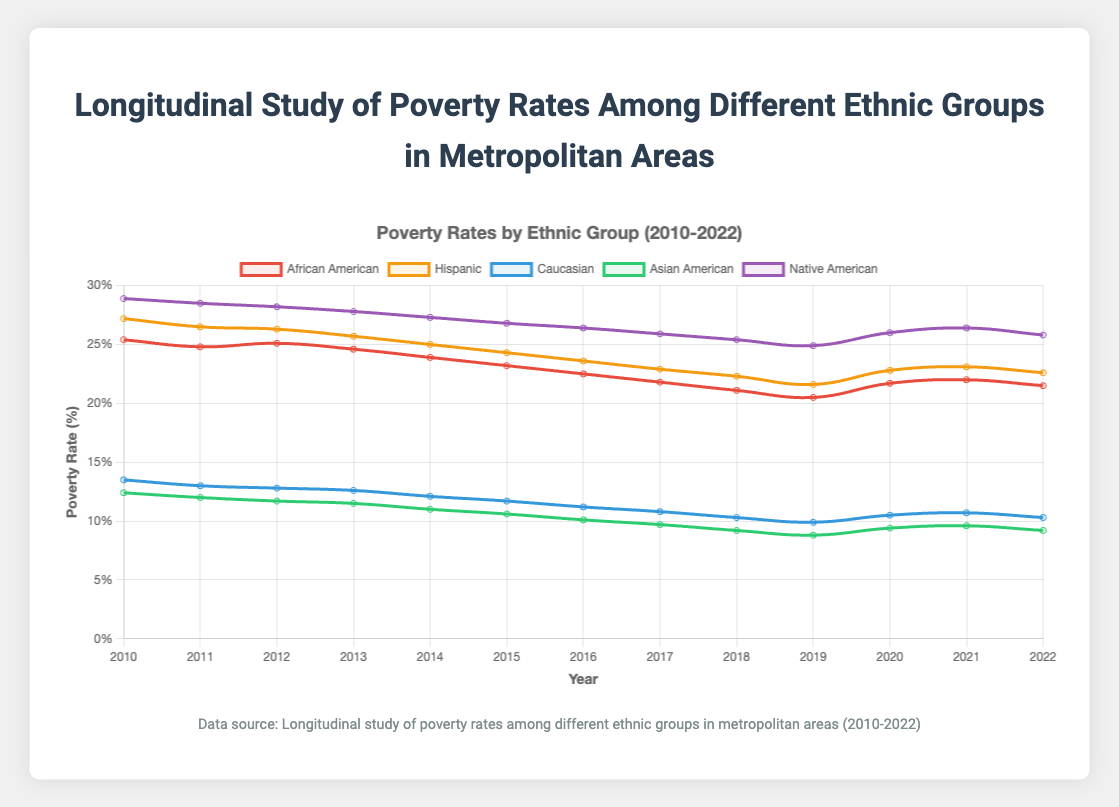What are the highest and lowest poverty rates for the Hispanic group between 2010 and 2022? The highest poverty rate for Hispanics is in 2010 at 27.2%, and the lowest is in 2019 at 21.6%
Answer: Highest: 27.2%, Lowest: 21.6% Which ethnic group had the lowest poverty rate in 2012? By examining the values for 2012, Caucasians had the lowest poverty rate at 12.8%
Answer: Caucasian Between 2010 and 2013, did the Native American poverty rate increase or decrease overall? In 2010, the rate is 28.9%, and by 2013 it is 27.8%. Since 27.8% is less than 28.9%, the overall trend is a decrease
Answer: Decrease Which group had the largest rise in poverty rate from 2019 to 2020? Between 2019 and 2020, the change for African Americans is +1.2, for Hispanics is +1.2, for Caucasians is +0.6, for Asian Americans is +0.6, and for Native Americans is +1.1. The tied highest increase is 1.2, so African Americans and Hispanics had the largest rise
Answer: African American, Hispanic From 2010 to 2022, how does the poverty rate of Asian Americans compare to that of Caucasians? The poverty rate for Asian Americans decreases from 12.4% to 9.2%, while that for Caucasians decreases from 13.5% to 10.3%. Thus, both groups experienced a decrease, but Asian Americans consistently had lower rates except in 2010
Answer: Both decreased; Asian Americans consistently lower except in 2010 What is the overall trend in the poverty rate for African Americans from 2010 to 2022? The poverty rate for African Americans decreases from 25.4% in 2010 to 21.5% in 2022, showing a decreasing trend
Answer: Decreasing trend Which ethnic group had the greatest fluctuation in poverty rates between 2010 and 2022? Native Americans had rates ranging from 28.9% to 25.4%, a difference of 3.5 percentage points, while African Americans' range is 3.6 (25.4 to 21.8), Hispanics is 3.1 (27.2 to 22.3), Caucasians is 3.7 (13.5 to 10.3), and Asian Americans is 4.0 (12.4 to 8.8). Hence, Caucasians had the highest fluctuation
Answer: Caucasian By how much did the Hispanic poverty rate change between 2010 and 2022? The poverty rate for Hispanics was 27.2% in 2010 and 22.6% in 2022, resulting in a change of 27.2 - 22.6 = 4.6 percentage points
Answer: 4.6 percentage points Are there any years where the poverty rate of one group increased while all others experienced a decrease? Looking at the data year by year, in 2020, all groups had an increase in their poverty rates. However, in 2021, the Hispanic and African American poverty rates increased while others either increased or held steady
Answer: 2021 for Hispanic & African American Which group saw the largest decrease in poverty rates from 2010 to 2022? For each group: African Americans decreased 3.9, Hispanics decreased 4.6, Caucasians decreased 3.2, Asian Americans decreased 3.2, Native Americans decreased 3.1. The largest decrease was for Hispanics
Answer: Hispanic 